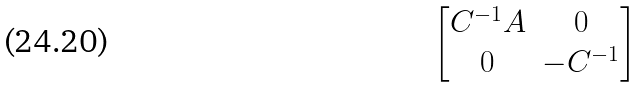<formula> <loc_0><loc_0><loc_500><loc_500>\begin{bmatrix} C ^ { - 1 } A & 0 \\ 0 & - C ^ { - 1 } \end{bmatrix}</formula> 